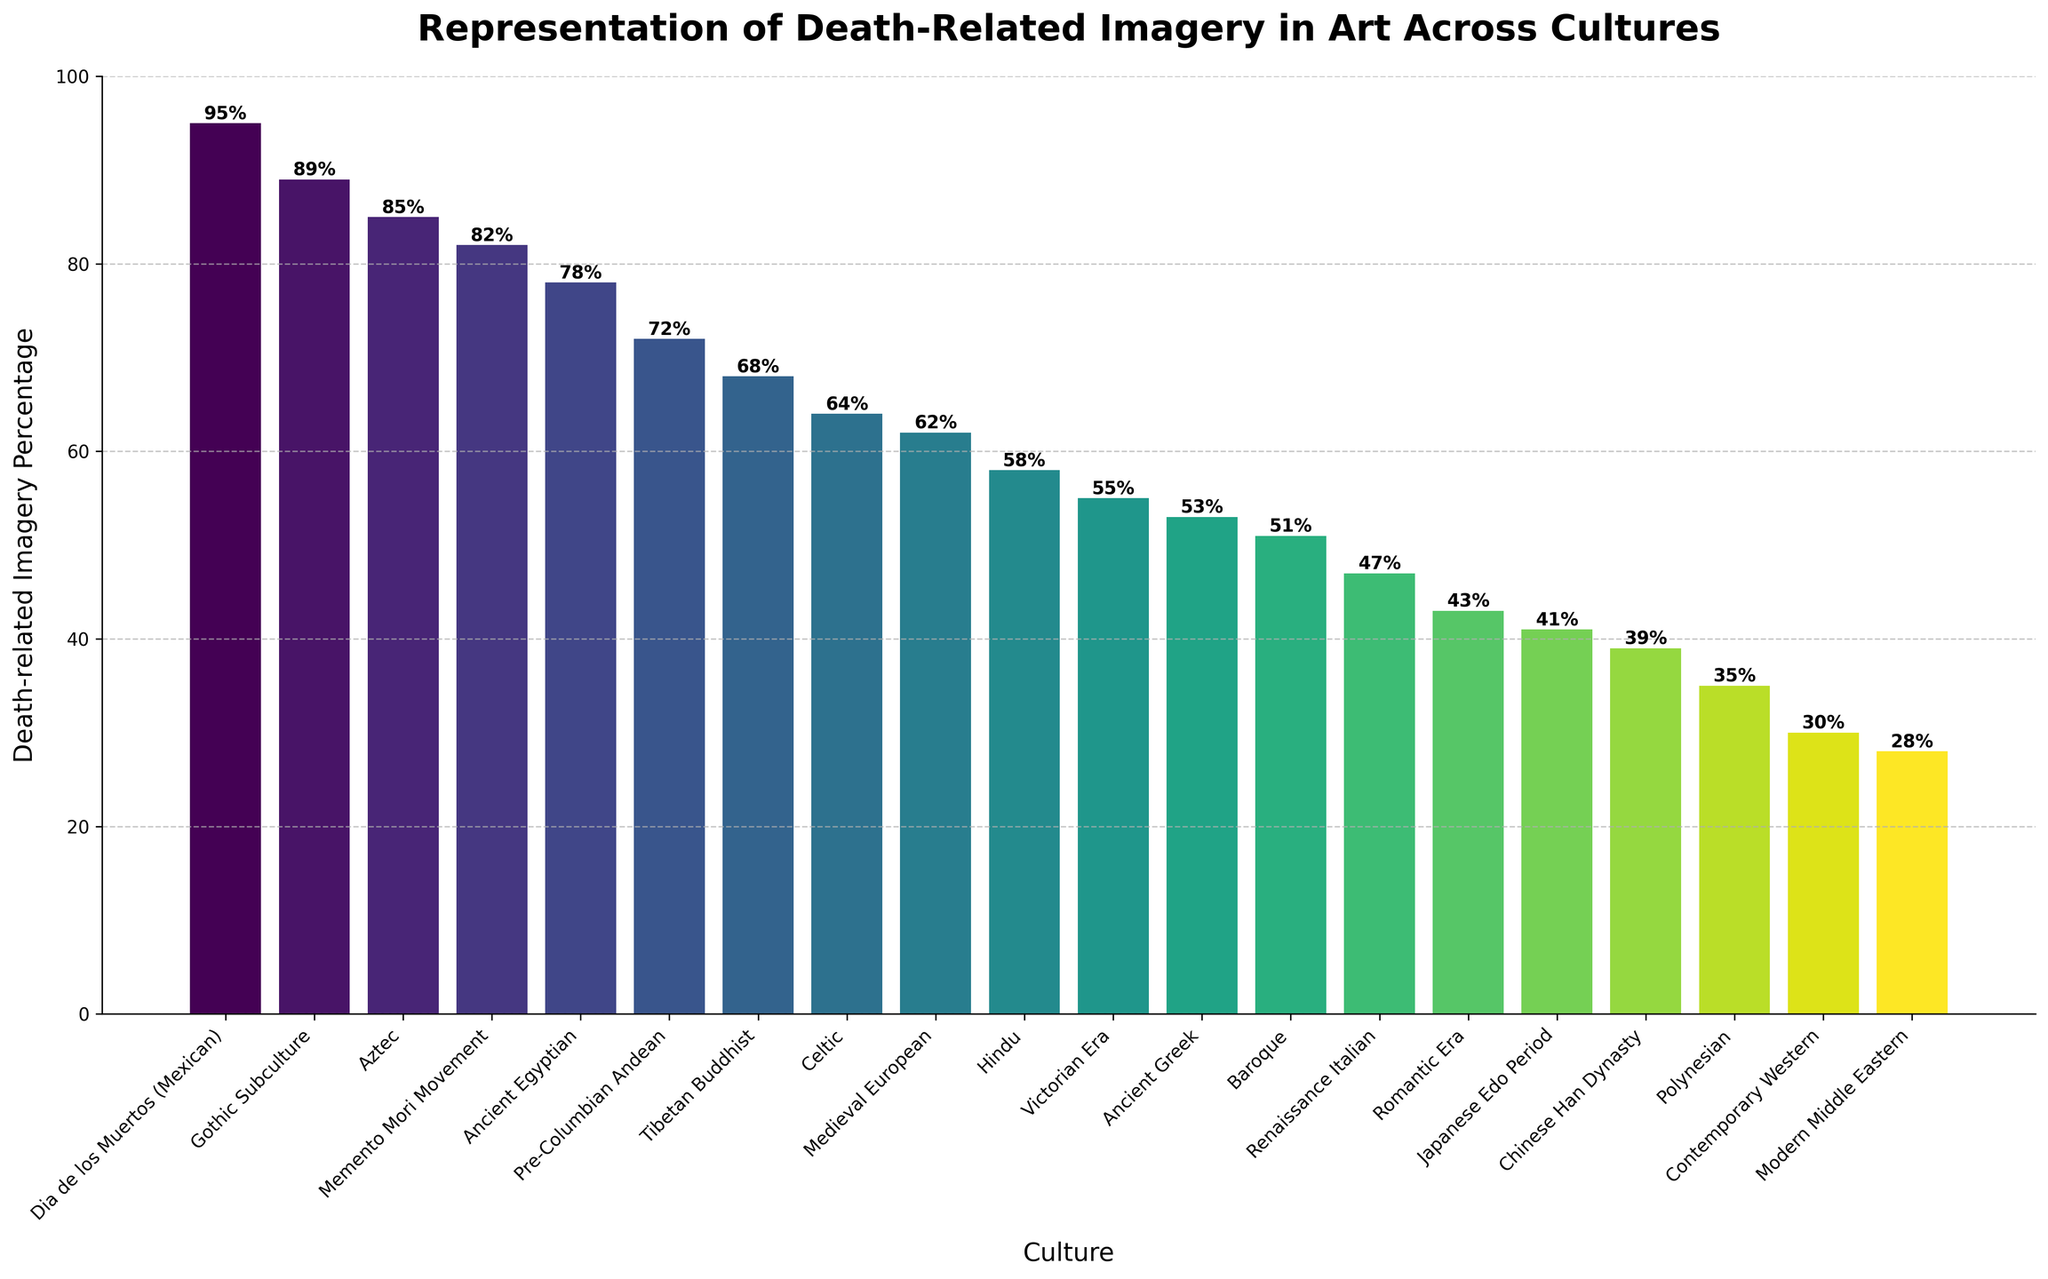Which culture has the highest percentage of death-related imagery? The figure's bars indicate the percentage of death-related imagery for different cultures, with the highest bar at 95% representing Dia de los Muertos (Mexican).
Answer: Dia de los Muertos (Mexican) Which two cultures have the closest percentages of death-related imagery? From the figure, the values for Gothic Subculture and Aztec are close, with percentages of 89% and 85%, respectively.
Answer: Gothic Subculture and Aztec What is the average percentage of death-related imagery for Ancient Egyptian, Medieval European, and Victorian Era cultures? Add the percentages for these three cultures: 78 + 62 + 55 = 195. Then divide by 3: 195 / 3 = 65.
Answer: 65 Which culture has a slightly lower percentage of death-related imagery than Ancient Egyptian? The figure shows Ancient Egyptian at 78%, and the next lowest percentage is Pre-Columbian Andean at 72%.
Answer: Pre-Columbian Andean Which culture has a percentage of death-related imagery between 50% and 60%? The figure shows that the percentage for Hindu culture is 58%, which is between 50% and 60%.
Answer: Hindu How many cultures have a death-related imagery percentage higher than 60%? Count the cultures with percentages higher than 60% from the bars. These are Ancient Egyptian, Medieval European, Aztec, Tibetan Buddhist, Pre-Columbian Andean, and Gothic Subculture, giving a total of six cultures.
Answer: Six What is the combined percentage of death-related imagery for the top three cultures? Sum the percentages for Dia de los Muertos (Mexican), Gothic Subculture, and Aztec: 95 + 89 + 85 = 269.
Answer: 269 What color makes up the bar for the Japanese Edo Period, visually speaking? Use the color gradient in the figure. Japanese Edo Period falls around 41% in the middle range of the viridis colormap, which appears greenish.
Answer: Greenish Is the percentage of death-related imagery for the Romantic Era higher or lower than that of the Baroque period? The figure shows the Romantic Era at 43% and the Baroque period at 51%, so the Romantic Era is lower.
Answer: Lower 